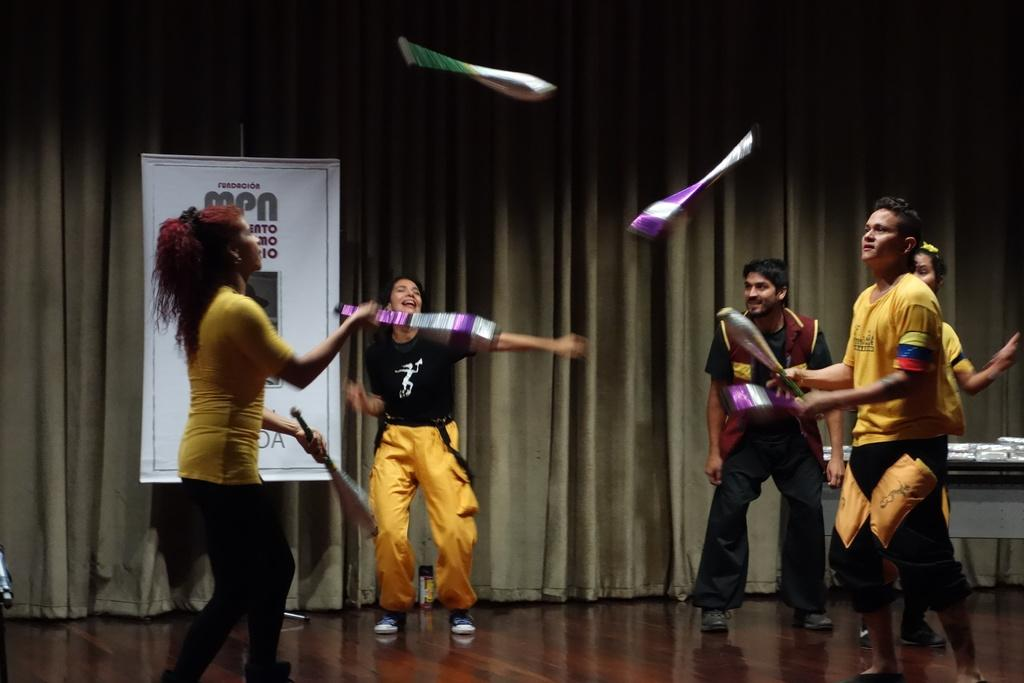What are the two people holding in the image? The two people are holding objects, but the specific objects are not mentioned in the facts. What can be seen in the background of the image? There is a table, a curtain, a hoarding, and people in the background of the image. What is on the table in the background? The facts mention that there are things on the table, but the specific items are not described. Can you see any rabbits or pets in the image? There is no mention of rabbits or pets in the provided facts, so we cannot determine their presence in the image. What type of vegetable is being prepared on the table in the image? The facts do not mention any vegetables or preparation activities, so we cannot answer this question. 